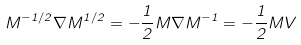Convert formula to latex. <formula><loc_0><loc_0><loc_500><loc_500>M ^ { - 1 / 2 } { \nabla } M ^ { 1 / 2 } = - { \frac { 1 } { 2 } } M { \nabla } M ^ { - 1 } = - { \frac { 1 } { 2 } } M { V }</formula> 